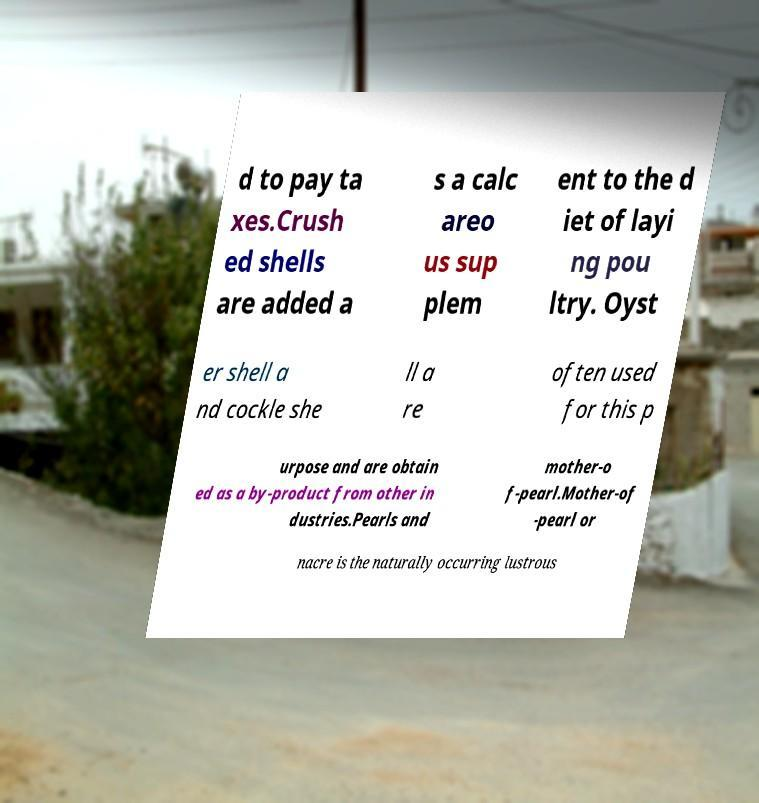Please identify and transcribe the text found in this image. d to pay ta xes.Crush ed shells are added a s a calc areo us sup plem ent to the d iet of layi ng pou ltry. Oyst er shell a nd cockle she ll a re often used for this p urpose and are obtain ed as a by-product from other in dustries.Pearls and mother-o f-pearl.Mother-of -pearl or nacre is the naturally occurring lustrous 